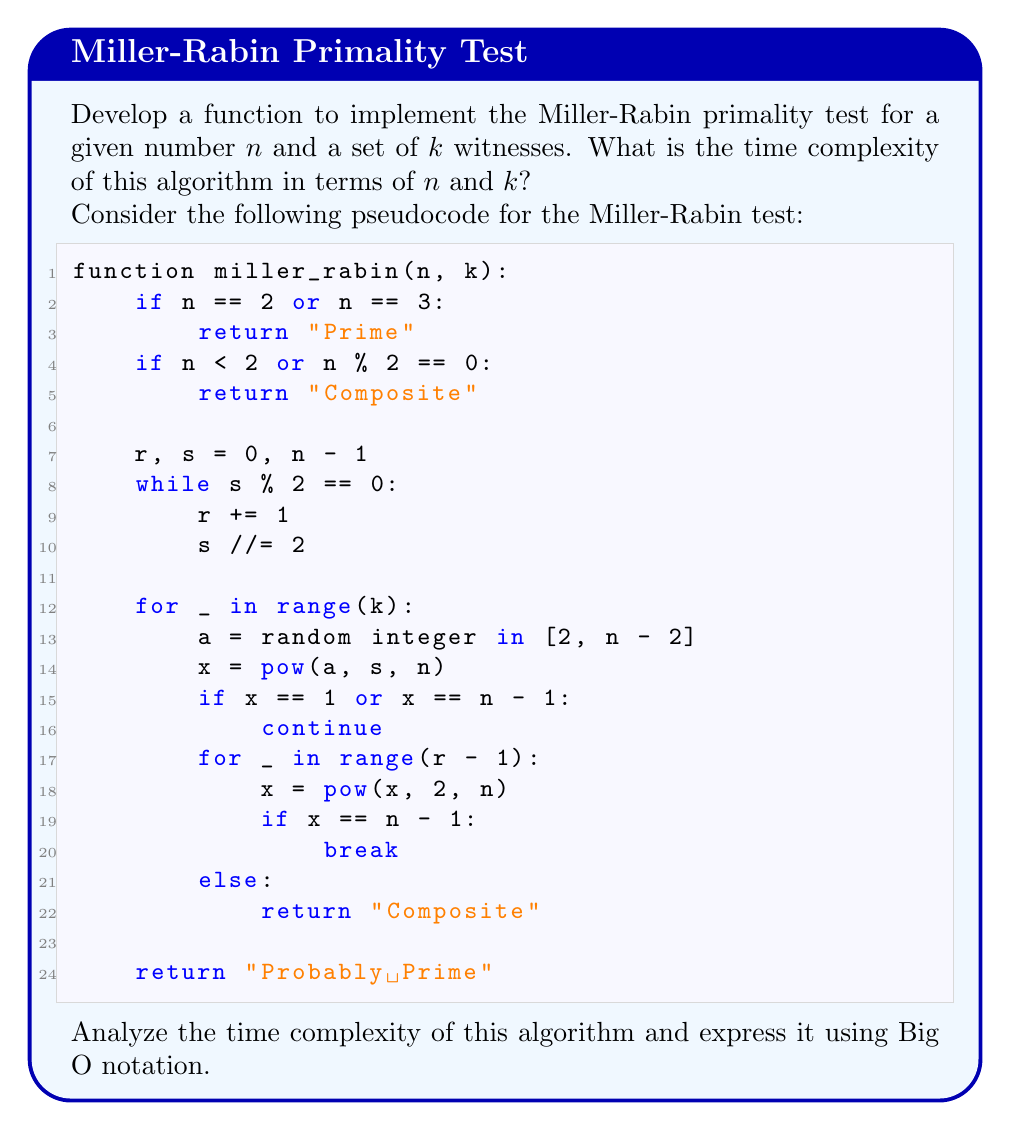Can you solve this math problem? To determine the time complexity of the Miller-Rabin primality test, we need to analyze the main operations in the algorithm:

1. Finding $r$ and $s$:
   This step involves dividing $n-1$ by 2 repeatedly. In the worst case, this takes $O(\log n)$ time.

2. Main loop:
   The outer loop runs $k$ times, where $k$ is the number of witnesses.

3. Inside the main loop:
   a. Generating a random number: $O(1)$
   b. Modular exponentiation: $pow(a, s, n)$ takes $O(\log s)$ time, which is $O(\log n)$ in the worst case.
   c. Inner loop: This loop runs at most $r-1$ times, where $r \leq \log_2 n$.
      Each iteration performs a modular squaring, which takes $O(\log n)$ time.

Combining these operations:

- The cost of one iteration of the main loop is $O(\log n) + O(r \log n) = O(\log^2 n)$
- The main loop runs $k$ times

Therefore, the overall time complexity is:

$$O(k \log^2 n)$$

This complexity accounts for:
- $k$: number of witnesses
- $\log^2 n$: cost of modular exponentiation and repeated squaring

Note that the space complexity is $O(\log n)$ to store the variables and intermediate results.

For cryptographic applications, $k$ is usually chosen as a fixed value (e.g., 40), making it effectively constant. In this case, the time complexity can be simplified to $O(\log^2 n)$.
Answer: $O(k \log^2 n)$ 